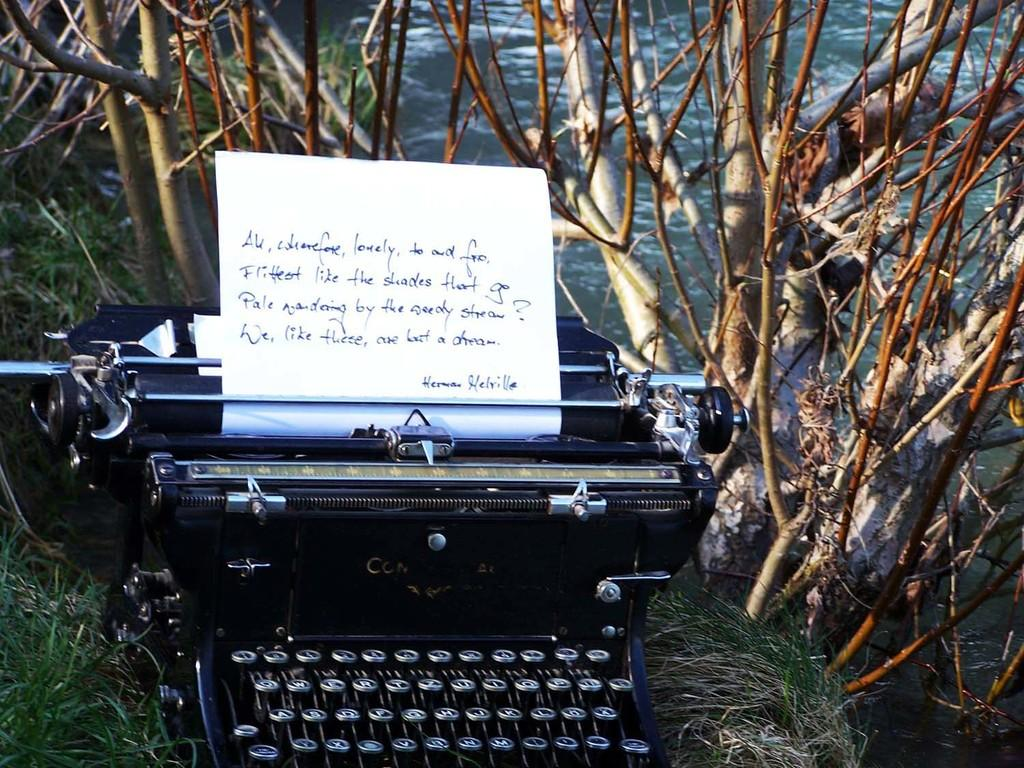<image>
Present a compact description of the photo's key features. A piece of paper with handwriting on it that's signed by Herman Melville sticks out of an old fashioned typewriter. 